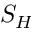<formula> <loc_0><loc_0><loc_500><loc_500>S _ { H }</formula> 